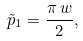<formula> <loc_0><loc_0><loc_500><loc_500>\tilde { p } _ { 1 } = { \frac { \pi \, w } { 2 } } ,</formula> 